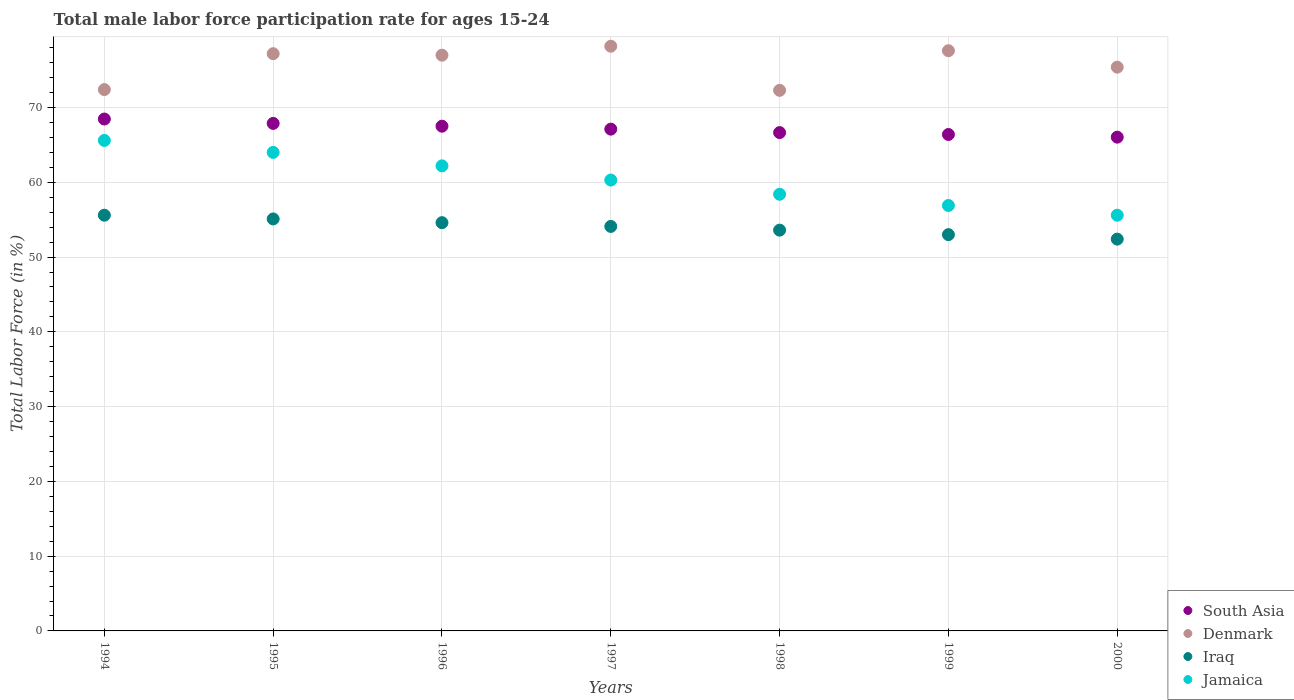How many different coloured dotlines are there?
Your response must be concise. 4. Is the number of dotlines equal to the number of legend labels?
Your answer should be very brief. Yes. What is the male labor force participation rate in Denmark in 1996?
Provide a succinct answer. 77. Across all years, what is the maximum male labor force participation rate in Iraq?
Ensure brevity in your answer.  55.6. Across all years, what is the minimum male labor force participation rate in Jamaica?
Give a very brief answer. 55.6. In which year was the male labor force participation rate in South Asia minimum?
Ensure brevity in your answer.  2000. What is the total male labor force participation rate in Iraq in the graph?
Make the answer very short. 378.4. What is the difference between the male labor force participation rate in Iraq in 1996 and that in 1999?
Give a very brief answer. 1.6. What is the difference between the male labor force participation rate in South Asia in 1998 and the male labor force participation rate in Jamaica in 1999?
Your answer should be very brief. 9.75. What is the average male labor force participation rate in Denmark per year?
Make the answer very short. 75.73. In the year 2000, what is the difference between the male labor force participation rate in Jamaica and male labor force participation rate in South Asia?
Your answer should be compact. -10.44. What is the ratio of the male labor force participation rate in Denmark in 1996 to that in 1999?
Offer a terse response. 0.99. Is the difference between the male labor force participation rate in Jamaica in 1996 and 1997 greater than the difference between the male labor force participation rate in South Asia in 1996 and 1997?
Your answer should be compact. Yes. What is the difference between the highest and the second highest male labor force participation rate in South Asia?
Provide a short and direct response. 0.58. What is the difference between the highest and the lowest male labor force participation rate in South Asia?
Your response must be concise. 2.42. In how many years, is the male labor force participation rate in Denmark greater than the average male labor force participation rate in Denmark taken over all years?
Make the answer very short. 4. Is the male labor force participation rate in Jamaica strictly greater than the male labor force participation rate in Iraq over the years?
Your response must be concise. Yes. Is the male labor force participation rate in Jamaica strictly less than the male labor force participation rate in Iraq over the years?
Your answer should be compact. No. Are the values on the major ticks of Y-axis written in scientific E-notation?
Your answer should be very brief. No. Where does the legend appear in the graph?
Keep it short and to the point. Bottom right. What is the title of the graph?
Keep it short and to the point. Total male labor force participation rate for ages 15-24. What is the label or title of the Y-axis?
Provide a short and direct response. Total Labor Force (in %). What is the Total Labor Force (in %) in South Asia in 1994?
Your answer should be very brief. 68.46. What is the Total Labor Force (in %) of Denmark in 1994?
Your response must be concise. 72.4. What is the Total Labor Force (in %) in Iraq in 1994?
Make the answer very short. 55.6. What is the Total Labor Force (in %) of Jamaica in 1994?
Your response must be concise. 65.6. What is the Total Labor Force (in %) of South Asia in 1995?
Keep it short and to the point. 67.88. What is the Total Labor Force (in %) in Denmark in 1995?
Ensure brevity in your answer.  77.2. What is the Total Labor Force (in %) in Iraq in 1995?
Make the answer very short. 55.1. What is the Total Labor Force (in %) of South Asia in 1996?
Offer a very short reply. 67.5. What is the Total Labor Force (in %) in Iraq in 1996?
Give a very brief answer. 54.6. What is the Total Labor Force (in %) of Jamaica in 1996?
Provide a succinct answer. 62.2. What is the Total Labor Force (in %) of South Asia in 1997?
Your answer should be compact. 67.11. What is the Total Labor Force (in %) of Denmark in 1997?
Ensure brevity in your answer.  78.2. What is the Total Labor Force (in %) in Iraq in 1997?
Your answer should be very brief. 54.1. What is the Total Labor Force (in %) in Jamaica in 1997?
Offer a terse response. 60.3. What is the Total Labor Force (in %) in South Asia in 1998?
Keep it short and to the point. 66.65. What is the Total Labor Force (in %) in Denmark in 1998?
Your response must be concise. 72.3. What is the Total Labor Force (in %) in Iraq in 1998?
Your response must be concise. 53.6. What is the Total Labor Force (in %) in Jamaica in 1998?
Ensure brevity in your answer.  58.4. What is the Total Labor Force (in %) in South Asia in 1999?
Provide a short and direct response. 66.4. What is the Total Labor Force (in %) of Denmark in 1999?
Provide a succinct answer. 77.6. What is the Total Labor Force (in %) in Iraq in 1999?
Give a very brief answer. 53. What is the Total Labor Force (in %) of Jamaica in 1999?
Offer a very short reply. 56.9. What is the Total Labor Force (in %) in South Asia in 2000?
Provide a succinct answer. 66.04. What is the Total Labor Force (in %) of Denmark in 2000?
Offer a very short reply. 75.4. What is the Total Labor Force (in %) in Iraq in 2000?
Provide a succinct answer. 52.4. What is the Total Labor Force (in %) in Jamaica in 2000?
Provide a succinct answer. 55.6. Across all years, what is the maximum Total Labor Force (in %) of South Asia?
Provide a succinct answer. 68.46. Across all years, what is the maximum Total Labor Force (in %) of Denmark?
Offer a terse response. 78.2. Across all years, what is the maximum Total Labor Force (in %) of Iraq?
Your answer should be compact. 55.6. Across all years, what is the maximum Total Labor Force (in %) in Jamaica?
Ensure brevity in your answer.  65.6. Across all years, what is the minimum Total Labor Force (in %) of South Asia?
Provide a succinct answer. 66.04. Across all years, what is the minimum Total Labor Force (in %) of Denmark?
Offer a terse response. 72.3. Across all years, what is the minimum Total Labor Force (in %) in Iraq?
Your response must be concise. 52.4. Across all years, what is the minimum Total Labor Force (in %) in Jamaica?
Your answer should be compact. 55.6. What is the total Total Labor Force (in %) in South Asia in the graph?
Your answer should be compact. 470.04. What is the total Total Labor Force (in %) in Denmark in the graph?
Keep it short and to the point. 530.1. What is the total Total Labor Force (in %) of Iraq in the graph?
Offer a very short reply. 378.4. What is the total Total Labor Force (in %) of Jamaica in the graph?
Your answer should be compact. 423. What is the difference between the Total Labor Force (in %) of South Asia in 1994 and that in 1995?
Your answer should be very brief. 0.58. What is the difference between the Total Labor Force (in %) of Denmark in 1994 and that in 1995?
Make the answer very short. -4.8. What is the difference between the Total Labor Force (in %) of Iraq in 1994 and that in 1995?
Make the answer very short. 0.5. What is the difference between the Total Labor Force (in %) of Jamaica in 1994 and that in 1995?
Your response must be concise. 1.6. What is the difference between the Total Labor Force (in %) of South Asia in 1994 and that in 1996?
Give a very brief answer. 0.96. What is the difference between the Total Labor Force (in %) of Denmark in 1994 and that in 1996?
Your answer should be very brief. -4.6. What is the difference between the Total Labor Force (in %) in Jamaica in 1994 and that in 1996?
Provide a succinct answer. 3.4. What is the difference between the Total Labor Force (in %) of South Asia in 1994 and that in 1997?
Keep it short and to the point. 1.35. What is the difference between the Total Labor Force (in %) of Iraq in 1994 and that in 1997?
Keep it short and to the point. 1.5. What is the difference between the Total Labor Force (in %) of South Asia in 1994 and that in 1998?
Your answer should be compact. 1.81. What is the difference between the Total Labor Force (in %) in South Asia in 1994 and that in 1999?
Provide a succinct answer. 2.07. What is the difference between the Total Labor Force (in %) in Denmark in 1994 and that in 1999?
Your answer should be very brief. -5.2. What is the difference between the Total Labor Force (in %) in Jamaica in 1994 and that in 1999?
Give a very brief answer. 8.7. What is the difference between the Total Labor Force (in %) in South Asia in 1994 and that in 2000?
Offer a terse response. 2.42. What is the difference between the Total Labor Force (in %) of Denmark in 1994 and that in 2000?
Make the answer very short. -3. What is the difference between the Total Labor Force (in %) of Jamaica in 1994 and that in 2000?
Offer a terse response. 10. What is the difference between the Total Labor Force (in %) in South Asia in 1995 and that in 1996?
Ensure brevity in your answer.  0.37. What is the difference between the Total Labor Force (in %) in Jamaica in 1995 and that in 1996?
Your answer should be very brief. 1.8. What is the difference between the Total Labor Force (in %) of South Asia in 1995 and that in 1997?
Your answer should be compact. 0.77. What is the difference between the Total Labor Force (in %) of Denmark in 1995 and that in 1997?
Ensure brevity in your answer.  -1. What is the difference between the Total Labor Force (in %) of Iraq in 1995 and that in 1997?
Keep it short and to the point. 1. What is the difference between the Total Labor Force (in %) of South Asia in 1995 and that in 1998?
Your answer should be compact. 1.23. What is the difference between the Total Labor Force (in %) in Denmark in 1995 and that in 1998?
Keep it short and to the point. 4.9. What is the difference between the Total Labor Force (in %) in South Asia in 1995 and that in 1999?
Provide a succinct answer. 1.48. What is the difference between the Total Labor Force (in %) of Iraq in 1995 and that in 1999?
Offer a terse response. 2.1. What is the difference between the Total Labor Force (in %) of Jamaica in 1995 and that in 1999?
Make the answer very short. 7.1. What is the difference between the Total Labor Force (in %) of South Asia in 1995 and that in 2000?
Your answer should be compact. 1.84. What is the difference between the Total Labor Force (in %) of Denmark in 1995 and that in 2000?
Your answer should be compact. 1.8. What is the difference between the Total Labor Force (in %) in Jamaica in 1995 and that in 2000?
Your response must be concise. 8.4. What is the difference between the Total Labor Force (in %) of South Asia in 1996 and that in 1997?
Make the answer very short. 0.39. What is the difference between the Total Labor Force (in %) of Iraq in 1996 and that in 1997?
Ensure brevity in your answer.  0.5. What is the difference between the Total Labor Force (in %) in Jamaica in 1996 and that in 1997?
Your answer should be compact. 1.9. What is the difference between the Total Labor Force (in %) of South Asia in 1996 and that in 1998?
Offer a terse response. 0.86. What is the difference between the Total Labor Force (in %) in Denmark in 1996 and that in 1998?
Provide a succinct answer. 4.7. What is the difference between the Total Labor Force (in %) in Iraq in 1996 and that in 1998?
Your response must be concise. 1. What is the difference between the Total Labor Force (in %) in South Asia in 1996 and that in 1999?
Provide a short and direct response. 1.11. What is the difference between the Total Labor Force (in %) of Denmark in 1996 and that in 1999?
Provide a succinct answer. -0.6. What is the difference between the Total Labor Force (in %) in Iraq in 1996 and that in 1999?
Offer a terse response. 1.6. What is the difference between the Total Labor Force (in %) in South Asia in 1996 and that in 2000?
Provide a short and direct response. 1.47. What is the difference between the Total Labor Force (in %) of Denmark in 1996 and that in 2000?
Offer a very short reply. 1.6. What is the difference between the Total Labor Force (in %) of Iraq in 1996 and that in 2000?
Provide a succinct answer. 2.2. What is the difference between the Total Labor Force (in %) in South Asia in 1997 and that in 1998?
Ensure brevity in your answer.  0.46. What is the difference between the Total Labor Force (in %) in South Asia in 1997 and that in 1999?
Your response must be concise. 0.72. What is the difference between the Total Labor Force (in %) in Iraq in 1997 and that in 1999?
Offer a terse response. 1.1. What is the difference between the Total Labor Force (in %) of Jamaica in 1997 and that in 1999?
Keep it short and to the point. 3.4. What is the difference between the Total Labor Force (in %) of South Asia in 1997 and that in 2000?
Your answer should be very brief. 1.07. What is the difference between the Total Labor Force (in %) of Iraq in 1997 and that in 2000?
Your answer should be compact. 1.7. What is the difference between the Total Labor Force (in %) in South Asia in 1998 and that in 1999?
Give a very brief answer. 0.25. What is the difference between the Total Labor Force (in %) of Denmark in 1998 and that in 1999?
Ensure brevity in your answer.  -5.3. What is the difference between the Total Labor Force (in %) in Iraq in 1998 and that in 1999?
Offer a very short reply. 0.6. What is the difference between the Total Labor Force (in %) of Jamaica in 1998 and that in 1999?
Your answer should be compact. 1.5. What is the difference between the Total Labor Force (in %) of South Asia in 1998 and that in 2000?
Make the answer very short. 0.61. What is the difference between the Total Labor Force (in %) in Denmark in 1998 and that in 2000?
Provide a short and direct response. -3.1. What is the difference between the Total Labor Force (in %) of South Asia in 1999 and that in 2000?
Your answer should be compact. 0.36. What is the difference between the Total Labor Force (in %) in Iraq in 1999 and that in 2000?
Offer a very short reply. 0.6. What is the difference between the Total Labor Force (in %) in Jamaica in 1999 and that in 2000?
Your answer should be very brief. 1.3. What is the difference between the Total Labor Force (in %) of South Asia in 1994 and the Total Labor Force (in %) of Denmark in 1995?
Your answer should be compact. -8.74. What is the difference between the Total Labor Force (in %) in South Asia in 1994 and the Total Labor Force (in %) in Iraq in 1995?
Provide a short and direct response. 13.36. What is the difference between the Total Labor Force (in %) in South Asia in 1994 and the Total Labor Force (in %) in Jamaica in 1995?
Offer a very short reply. 4.46. What is the difference between the Total Labor Force (in %) of Denmark in 1994 and the Total Labor Force (in %) of Jamaica in 1995?
Ensure brevity in your answer.  8.4. What is the difference between the Total Labor Force (in %) of Iraq in 1994 and the Total Labor Force (in %) of Jamaica in 1995?
Your answer should be very brief. -8.4. What is the difference between the Total Labor Force (in %) of South Asia in 1994 and the Total Labor Force (in %) of Denmark in 1996?
Offer a terse response. -8.54. What is the difference between the Total Labor Force (in %) of South Asia in 1994 and the Total Labor Force (in %) of Iraq in 1996?
Keep it short and to the point. 13.86. What is the difference between the Total Labor Force (in %) in South Asia in 1994 and the Total Labor Force (in %) in Jamaica in 1996?
Provide a short and direct response. 6.26. What is the difference between the Total Labor Force (in %) in Iraq in 1994 and the Total Labor Force (in %) in Jamaica in 1996?
Your answer should be very brief. -6.6. What is the difference between the Total Labor Force (in %) in South Asia in 1994 and the Total Labor Force (in %) in Denmark in 1997?
Your answer should be very brief. -9.74. What is the difference between the Total Labor Force (in %) of South Asia in 1994 and the Total Labor Force (in %) of Iraq in 1997?
Your answer should be very brief. 14.36. What is the difference between the Total Labor Force (in %) of South Asia in 1994 and the Total Labor Force (in %) of Jamaica in 1997?
Provide a succinct answer. 8.16. What is the difference between the Total Labor Force (in %) in South Asia in 1994 and the Total Labor Force (in %) in Denmark in 1998?
Keep it short and to the point. -3.84. What is the difference between the Total Labor Force (in %) in South Asia in 1994 and the Total Labor Force (in %) in Iraq in 1998?
Your response must be concise. 14.86. What is the difference between the Total Labor Force (in %) of South Asia in 1994 and the Total Labor Force (in %) of Jamaica in 1998?
Give a very brief answer. 10.06. What is the difference between the Total Labor Force (in %) in South Asia in 1994 and the Total Labor Force (in %) in Denmark in 1999?
Provide a succinct answer. -9.14. What is the difference between the Total Labor Force (in %) of South Asia in 1994 and the Total Labor Force (in %) of Iraq in 1999?
Offer a very short reply. 15.46. What is the difference between the Total Labor Force (in %) of South Asia in 1994 and the Total Labor Force (in %) of Jamaica in 1999?
Your answer should be very brief. 11.56. What is the difference between the Total Labor Force (in %) in Denmark in 1994 and the Total Labor Force (in %) in Iraq in 1999?
Ensure brevity in your answer.  19.4. What is the difference between the Total Labor Force (in %) in Iraq in 1994 and the Total Labor Force (in %) in Jamaica in 1999?
Give a very brief answer. -1.3. What is the difference between the Total Labor Force (in %) of South Asia in 1994 and the Total Labor Force (in %) of Denmark in 2000?
Your response must be concise. -6.94. What is the difference between the Total Labor Force (in %) in South Asia in 1994 and the Total Labor Force (in %) in Iraq in 2000?
Your answer should be very brief. 16.06. What is the difference between the Total Labor Force (in %) in South Asia in 1994 and the Total Labor Force (in %) in Jamaica in 2000?
Provide a short and direct response. 12.86. What is the difference between the Total Labor Force (in %) of Denmark in 1994 and the Total Labor Force (in %) of Iraq in 2000?
Provide a succinct answer. 20. What is the difference between the Total Labor Force (in %) of Iraq in 1994 and the Total Labor Force (in %) of Jamaica in 2000?
Keep it short and to the point. 0. What is the difference between the Total Labor Force (in %) of South Asia in 1995 and the Total Labor Force (in %) of Denmark in 1996?
Make the answer very short. -9.12. What is the difference between the Total Labor Force (in %) in South Asia in 1995 and the Total Labor Force (in %) in Iraq in 1996?
Make the answer very short. 13.28. What is the difference between the Total Labor Force (in %) of South Asia in 1995 and the Total Labor Force (in %) of Jamaica in 1996?
Offer a very short reply. 5.68. What is the difference between the Total Labor Force (in %) in Denmark in 1995 and the Total Labor Force (in %) in Iraq in 1996?
Your answer should be compact. 22.6. What is the difference between the Total Labor Force (in %) in Iraq in 1995 and the Total Labor Force (in %) in Jamaica in 1996?
Offer a terse response. -7.1. What is the difference between the Total Labor Force (in %) of South Asia in 1995 and the Total Labor Force (in %) of Denmark in 1997?
Make the answer very short. -10.32. What is the difference between the Total Labor Force (in %) of South Asia in 1995 and the Total Labor Force (in %) of Iraq in 1997?
Provide a short and direct response. 13.78. What is the difference between the Total Labor Force (in %) in South Asia in 1995 and the Total Labor Force (in %) in Jamaica in 1997?
Provide a succinct answer. 7.58. What is the difference between the Total Labor Force (in %) in Denmark in 1995 and the Total Labor Force (in %) in Iraq in 1997?
Offer a terse response. 23.1. What is the difference between the Total Labor Force (in %) in Denmark in 1995 and the Total Labor Force (in %) in Jamaica in 1997?
Offer a very short reply. 16.9. What is the difference between the Total Labor Force (in %) in Iraq in 1995 and the Total Labor Force (in %) in Jamaica in 1997?
Offer a terse response. -5.2. What is the difference between the Total Labor Force (in %) in South Asia in 1995 and the Total Labor Force (in %) in Denmark in 1998?
Your answer should be very brief. -4.42. What is the difference between the Total Labor Force (in %) of South Asia in 1995 and the Total Labor Force (in %) of Iraq in 1998?
Provide a succinct answer. 14.28. What is the difference between the Total Labor Force (in %) of South Asia in 1995 and the Total Labor Force (in %) of Jamaica in 1998?
Give a very brief answer. 9.48. What is the difference between the Total Labor Force (in %) of Denmark in 1995 and the Total Labor Force (in %) of Iraq in 1998?
Your answer should be very brief. 23.6. What is the difference between the Total Labor Force (in %) in Denmark in 1995 and the Total Labor Force (in %) in Jamaica in 1998?
Offer a very short reply. 18.8. What is the difference between the Total Labor Force (in %) of Iraq in 1995 and the Total Labor Force (in %) of Jamaica in 1998?
Ensure brevity in your answer.  -3.3. What is the difference between the Total Labor Force (in %) of South Asia in 1995 and the Total Labor Force (in %) of Denmark in 1999?
Provide a short and direct response. -9.72. What is the difference between the Total Labor Force (in %) in South Asia in 1995 and the Total Labor Force (in %) in Iraq in 1999?
Your answer should be very brief. 14.88. What is the difference between the Total Labor Force (in %) in South Asia in 1995 and the Total Labor Force (in %) in Jamaica in 1999?
Make the answer very short. 10.98. What is the difference between the Total Labor Force (in %) in Denmark in 1995 and the Total Labor Force (in %) in Iraq in 1999?
Provide a succinct answer. 24.2. What is the difference between the Total Labor Force (in %) of Denmark in 1995 and the Total Labor Force (in %) of Jamaica in 1999?
Provide a succinct answer. 20.3. What is the difference between the Total Labor Force (in %) in Iraq in 1995 and the Total Labor Force (in %) in Jamaica in 1999?
Ensure brevity in your answer.  -1.8. What is the difference between the Total Labor Force (in %) of South Asia in 1995 and the Total Labor Force (in %) of Denmark in 2000?
Offer a terse response. -7.52. What is the difference between the Total Labor Force (in %) of South Asia in 1995 and the Total Labor Force (in %) of Iraq in 2000?
Your answer should be compact. 15.48. What is the difference between the Total Labor Force (in %) in South Asia in 1995 and the Total Labor Force (in %) in Jamaica in 2000?
Your answer should be compact. 12.28. What is the difference between the Total Labor Force (in %) of Denmark in 1995 and the Total Labor Force (in %) of Iraq in 2000?
Your answer should be very brief. 24.8. What is the difference between the Total Labor Force (in %) of Denmark in 1995 and the Total Labor Force (in %) of Jamaica in 2000?
Ensure brevity in your answer.  21.6. What is the difference between the Total Labor Force (in %) in South Asia in 1996 and the Total Labor Force (in %) in Denmark in 1997?
Provide a short and direct response. -10.7. What is the difference between the Total Labor Force (in %) of South Asia in 1996 and the Total Labor Force (in %) of Iraq in 1997?
Your response must be concise. 13.4. What is the difference between the Total Labor Force (in %) of South Asia in 1996 and the Total Labor Force (in %) of Jamaica in 1997?
Provide a short and direct response. 7.2. What is the difference between the Total Labor Force (in %) of Denmark in 1996 and the Total Labor Force (in %) of Iraq in 1997?
Keep it short and to the point. 22.9. What is the difference between the Total Labor Force (in %) of Iraq in 1996 and the Total Labor Force (in %) of Jamaica in 1997?
Give a very brief answer. -5.7. What is the difference between the Total Labor Force (in %) in South Asia in 1996 and the Total Labor Force (in %) in Denmark in 1998?
Offer a terse response. -4.8. What is the difference between the Total Labor Force (in %) of South Asia in 1996 and the Total Labor Force (in %) of Iraq in 1998?
Make the answer very short. 13.9. What is the difference between the Total Labor Force (in %) of South Asia in 1996 and the Total Labor Force (in %) of Jamaica in 1998?
Ensure brevity in your answer.  9.1. What is the difference between the Total Labor Force (in %) of Denmark in 1996 and the Total Labor Force (in %) of Iraq in 1998?
Offer a very short reply. 23.4. What is the difference between the Total Labor Force (in %) in Denmark in 1996 and the Total Labor Force (in %) in Jamaica in 1998?
Ensure brevity in your answer.  18.6. What is the difference between the Total Labor Force (in %) of South Asia in 1996 and the Total Labor Force (in %) of Denmark in 1999?
Keep it short and to the point. -10.1. What is the difference between the Total Labor Force (in %) of South Asia in 1996 and the Total Labor Force (in %) of Iraq in 1999?
Ensure brevity in your answer.  14.5. What is the difference between the Total Labor Force (in %) of South Asia in 1996 and the Total Labor Force (in %) of Jamaica in 1999?
Offer a very short reply. 10.6. What is the difference between the Total Labor Force (in %) of Denmark in 1996 and the Total Labor Force (in %) of Jamaica in 1999?
Your response must be concise. 20.1. What is the difference between the Total Labor Force (in %) of South Asia in 1996 and the Total Labor Force (in %) of Denmark in 2000?
Keep it short and to the point. -7.9. What is the difference between the Total Labor Force (in %) of South Asia in 1996 and the Total Labor Force (in %) of Iraq in 2000?
Make the answer very short. 15.1. What is the difference between the Total Labor Force (in %) of South Asia in 1996 and the Total Labor Force (in %) of Jamaica in 2000?
Offer a very short reply. 11.9. What is the difference between the Total Labor Force (in %) of Denmark in 1996 and the Total Labor Force (in %) of Iraq in 2000?
Make the answer very short. 24.6. What is the difference between the Total Labor Force (in %) in Denmark in 1996 and the Total Labor Force (in %) in Jamaica in 2000?
Your response must be concise. 21.4. What is the difference between the Total Labor Force (in %) in South Asia in 1997 and the Total Labor Force (in %) in Denmark in 1998?
Offer a terse response. -5.19. What is the difference between the Total Labor Force (in %) in South Asia in 1997 and the Total Labor Force (in %) in Iraq in 1998?
Offer a terse response. 13.51. What is the difference between the Total Labor Force (in %) of South Asia in 1997 and the Total Labor Force (in %) of Jamaica in 1998?
Ensure brevity in your answer.  8.71. What is the difference between the Total Labor Force (in %) of Denmark in 1997 and the Total Labor Force (in %) of Iraq in 1998?
Make the answer very short. 24.6. What is the difference between the Total Labor Force (in %) of Denmark in 1997 and the Total Labor Force (in %) of Jamaica in 1998?
Give a very brief answer. 19.8. What is the difference between the Total Labor Force (in %) of South Asia in 1997 and the Total Labor Force (in %) of Denmark in 1999?
Your response must be concise. -10.49. What is the difference between the Total Labor Force (in %) of South Asia in 1997 and the Total Labor Force (in %) of Iraq in 1999?
Make the answer very short. 14.11. What is the difference between the Total Labor Force (in %) of South Asia in 1997 and the Total Labor Force (in %) of Jamaica in 1999?
Offer a very short reply. 10.21. What is the difference between the Total Labor Force (in %) of Denmark in 1997 and the Total Labor Force (in %) of Iraq in 1999?
Keep it short and to the point. 25.2. What is the difference between the Total Labor Force (in %) of Denmark in 1997 and the Total Labor Force (in %) of Jamaica in 1999?
Ensure brevity in your answer.  21.3. What is the difference between the Total Labor Force (in %) of South Asia in 1997 and the Total Labor Force (in %) of Denmark in 2000?
Keep it short and to the point. -8.29. What is the difference between the Total Labor Force (in %) in South Asia in 1997 and the Total Labor Force (in %) in Iraq in 2000?
Give a very brief answer. 14.71. What is the difference between the Total Labor Force (in %) of South Asia in 1997 and the Total Labor Force (in %) of Jamaica in 2000?
Offer a terse response. 11.51. What is the difference between the Total Labor Force (in %) in Denmark in 1997 and the Total Labor Force (in %) in Iraq in 2000?
Provide a succinct answer. 25.8. What is the difference between the Total Labor Force (in %) of Denmark in 1997 and the Total Labor Force (in %) of Jamaica in 2000?
Ensure brevity in your answer.  22.6. What is the difference between the Total Labor Force (in %) of Iraq in 1997 and the Total Labor Force (in %) of Jamaica in 2000?
Give a very brief answer. -1.5. What is the difference between the Total Labor Force (in %) in South Asia in 1998 and the Total Labor Force (in %) in Denmark in 1999?
Keep it short and to the point. -10.95. What is the difference between the Total Labor Force (in %) in South Asia in 1998 and the Total Labor Force (in %) in Iraq in 1999?
Offer a terse response. 13.65. What is the difference between the Total Labor Force (in %) of South Asia in 1998 and the Total Labor Force (in %) of Jamaica in 1999?
Provide a short and direct response. 9.75. What is the difference between the Total Labor Force (in %) of Denmark in 1998 and the Total Labor Force (in %) of Iraq in 1999?
Your answer should be compact. 19.3. What is the difference between the Total Labor Force (in %) in Iraq in 1998 and the Total Labor Force (in %) in Jamaica in 1999?
Give a very brief answer. -3.3. What is the difference between the Total Labor Force (in %) of South Asia in 1998 and the Total Labor Force (in %) of Denmark in 2000?
Your response must be concise. -8.75. What is the difference between the Total Labor Force (in %) in South Asia in 1998 and the Total Labor Force (in %) in Iraq in 2000?
Provide a short and direct response. 14.25. What is the difference between the Total Labor Force (in %) of South Asia in 1998 and the Total Labor Force (in %) of Jamaica in 2000?
Offer a very short reply. 11.05. What is the difference between the Total Labor Force (in %) of Iraq in 1998 and the Total Labor Force (in %) of Jamaica in 2000?
Your response must be concise. -2. What is the difference between the Total Labor Force (in %) in South Asia in 1999 and the Total Labor Force (in %) in Denmark in 2000?
Provide a short and direct response. -9. What is the difference between the Total Labor Force (in %) in South Asia in 1999 and the Total Labor Force (in %) in Iraq in 2000?
Ensure brevity in your answer.  14. What is the difference between the Total Labor Force (in %) in South Asia in 1999 and the Total Labor Force (in %) in Jamaica in 2000?
Give a very brief answer. 10.8. What is the difference between the Total Labor Force (in %) of Denmark in 1999 and the Total Labor Force (in %) of Iraq in 2000?
Make the answer very short. 25.2. What is the difference between the Total Labor Force (in %) in Iraq in 1999 and the Total Labor Force (in %) in Jamaica in 2000?
Your response must be concise. -2.6. What is the average Total Labor Force (in %) of South Asia per year?
Keep it short and to the point. 67.15. What is the average Total Labor Force (in %) of Denmark per year?
Give a very brief answer. 75.73. What is the average Total Labor Force (in %) of Iraq per year?
Ensure brevity in your answer.  54.06. What is the average Total Labor Force (in %) in Jamaica per year?
Offer a terse response. 60.43. In the year 1994, what is the difference between the Total Labor Force (in %) of South Asia and Total Labor Force (in %) of Denmark?
Provide a succinct answer. -3.94. In the year 1994, what is the difference between the Total Labor Force (in %) in South Asia and Total Labor Force (in %) in Iraq?
Make the answer very short. 12.86. In the year 1994, what is the difference between the Total Labor Force (in %) in South Asia and Total Labor Force (in %) in Jamaica?
Your answer should be compact. 2.86. In the year 1994, what is the difference between the Total Labor Force (in %) of Denmark and Total Labor Force (in %) of Jamaica?
Keep it short and to the point. 6.8. In the year 1994, what is the difference between the Total Labor Force (in %) in Iraq and Total Labor Force (in %) in Jamaica?
Keep it short and to the point. -10. In the year 1995, what is the difference between the Total Labor Force (in %) in South Asia and Total Labor Force (in %) in Denmark?
Offer a very short reply. -9.32. In the year 1995, what is the difference between the Total Labor Force (in %) in South Asia and Total Labor Force (in %) in Iraq?
Offer a terse response. 12.78. In the year 1995, what is the difference between the Total Labor Force (in %) in South Asia and Total Labor Force (in %) in Jamaica?
Your response must be concise. 3.88. In the year 1995, what is the difference between the Total Labor Force (in %) of Denmark and Total Labor Force (in %) of Iraq?
Provide a short and direct response. 22.1. In the year 1996, what is the difference between the Total Labor Force (in %) of South Asia and Total Labor Force (in %) of Denmark?
Make the answer very short. -9.5. In the year 1996, what is the difference between the Total Labor Force (in %) of South Asia and Total Labor Force (in %) of Iraq?
Ensure brevity in your answer.  12.9. In the year 1996, what is the difference between the Total Labor Force (in %) in South Asia and Total Labor Force (in %) in Jamaica?
Give a very brief answer. 5.3. In the year 1996, what is the difference between the Total Labor Force (in %) of Denmark and Total Labor Force (in %) of Iraq?
Your answer should be compact. 22.4. In the year 1996, what is the difference between the Total Labor Force (in %) of Iraq and Total Labor Force (in %) of Jamaica?
Keep it short and to the point. -7.6. In the year 1997, what is the difference between the Total Labor Force (in %) of South Asia and Total Labor Force (in %) of Denmark?
Offer a terse response. -11.09. In the year 1997, what is the difference between the Total Labor Force (in %) of South Asia and Total Labor Force (in %) of Iraq?
Your response must be concise. 13.01. In the year 1997, what is the difference between the Total Labor Force (in %) in South Asia and Total Labor Force (in %) in Jamaica?
Provide a short and direct response. 6.81. In the year 1997, what is the difference between the Total Labor Force (in %) of Denmark and Total Labor Force (in %) of Iraq?
Keep it short and to the point. 24.1. In the year 1997, what is the difference between the Total Labor Force (in %) in Denmark and Total Labor Force (in %) in Jamaica?
Provide a short and direct response. 17.9. In the year 1998, what is the difference between the Total Labor Force (in %) in South Asia and Total Labor Force (in %) in Denmark?
Your response must be concise. -5.65. In the year 1998, what is the difference between the Total Labor Force (in %) in South Asia and Total Labor Force (in %) in Iraq?
Your answer should be compact. 13.05. In the year 1998, what is the difference between the Total Labor Force (in %) in South Asia and Total Labor Force (in %) in Jamaica?
Your answer should be compact. 8.25. In the year 1998, what is the difference between the Total Labor Force (in %) of Denmark and Total Labor Force (in %) of Jamaica?
Offer a terse response. 13.9. In the year 1999, what is the difference between the Total Labor Force (in %) of South Asia and Total Labor Force (in %) of Denmark?
Your response must be concise. -11.2. In the year 1999, what is the difference between the Total Labor Force (in %) of South Asia and Total Labor Force (in %) of Iraq?
Your answer should be compact. 13.4. In the year 1999, what is the difference between the Total Labor Force (in %) of South Asia and Total Labor Force (in %) of Jamaica?
Your answer should be very brief. 9.5. In the year 1999, what is the difference between the Total Labor Force (in %) of Denmark and Total Labor Force (in %) of Iraq?
Your answer should be very brief. 24.6. In the year 1999, what is the difference between the Total Labor Force (in %) of Denmark and Total Labor Force (in %) of Jamaica?
Your answer should be compact. 20.7. In the year 2000, what is the difference between the Total Labor Force (in %) in South Asia and Total Labor Force (in %) in Denmark?
Your answer should be compact. -9.36. In the year 2000, what is the difference between the Total Labor Force (in %) in South Asia and Total Labor Force (in %) in Iraq?
Your response must be concise. 13.64. In the year 2000, what is the difference between the Total Labor Force (in %) in South Asia and Total Labor Force (in %) in Jamaica?
Offer a very short reply. 10.44. In the year 2000, what is the difference between the Total Labor Force (in %) of Denmark and Total Labor Force (in %) of Iraq?
Give a very brief answer. 23. In the year 2000, what is the difference between the Total Labor Force (in %) of Denmark and Total Labor Force (in %) of Jamaica?
Offer a terse response. 19.8. In the year 2000, what is the difference between the Total Labor Force (in %) of Iraq and Total Labor Force (in %) of Jamaica?
Keep it short and to the point. -3.2. What is the ratio of the Total Labor Force (in %) of South Asia in 1994 to that in 1995?
Provide a succinct answer. 1.01. What is the ratio of the Total Labor Force (in %) in Denmark in 1994 to that in 1995?
Offer a very short reply. 0.94. What is the ratio of the Total Labor Force (in %) in Iraq in 1994 to that in 1995?
Give a very brief answer. 1.01. What is the ratio of the Total Labor Force (in %) in Jamaica in 1994 to that in 1995?
Provide a short and direct response. 1.02. What is the ratio of the Total Labor Force (in %) of South Asia in 1994 to that in 1996?
Offer a very short reply. 1.01. What is the ratio of the Total Labor Force (in %) in Denmark in 1994 to that in 1996?
Provide a short and direct response. 0.94. What is the ratio of the Total Labor Force (in %) in Iraq in 1994 to that in 1996?
Your response must be concise. 1.02. What is the ratio of the Total Labor Force (in %) of Jamaica in 1994 to that in 1996?
Ensure brevity in your answer.  1.05. What is the ratio of the Total Labor Force (in %) in South Asia in 1994 to that in 1997?
Your answer should be compact. 1.02. What is the ratio of the Total Labor Force (in %) in Denmark in 1994 to that in 1997?
Make the answer very short. 0.93. What is the ratio of the Total Labor Force (in %) of Iraq in 1994 to that in 1997?
Ensure brevity in your answer.  1.03. What is the ratio of the Total Labor Force (in %) in Jamaica in 1994 to that in 1997?
Offer a very short reply. 1.09. What is the ratio of the Total Labor Force (in %) in South Asia in 1994 to that in 1998?
Make the answer very short. 1.03. What is the ratio of the Total Labor Force (in %) of Denmark in 1994 to that in 1998?
Offer a very short reply. 1. What is the ratio of the Total Labor Force (in %) in Iraq in 1994 to that in 1998?
Provide a short and direct response. 1.04. What is the ratio of the Total Labor Force (in %) of Jamaica in 1994 to that in 1998?
Provide a short and direct response. 1.12. What is the ratio of the Total Labor Force (in %) of South Asia in 1994 to that in 1999?
Keep it short and to the point. 1.03. What is the ratio of the Total Labor Force (in %) of Denmark in 1994 to that in 1999?
Ensure brevity in your answer.  0.93. What is the ratio of the Total Labor Force (in %) of Iraq in 1994 to that in 1999?
Your response must be concise. 1.05. What is the ratio of the Total Labor Force (in %) of Jamaica in 1994 to that in 1999?
Your answer should be very brief. 1.15. What is the ratio of the Total Labor Force (in %) in South Asia in 1994 to that in 2000?
Your answer should be compact. 1.04. What is the ratio of the Total Labor Force (in %) in Denmark in 1994 to that in 2000?
Give a very brief answer. 0.96. What is the ratio of the Total Labor Force (in %) of Iraq in 1994 to that in 2000?
Offer a very short reply. 1.06. What is the ratio of the Total Labor Force (in %) in Jamaica in 1994 to that in 2000?
Ensure brevity in your answer.  1.18. What is the ratio of the Total Labor Force (in %) of South Asia in 1995 to that in 1996?
Offer a terse response. 1.01. What is the ratio of the Total Labor Force (in %) in Denmark in 1995 to that in 1996?
Your response must be concise. 1. What is the ratio of the Total Labor Force (in %) of Iraq in 1995 to that in 1996?
Make the answer very short. 1.01. What is the ratio of the Total Labor Force (in %) of Jamaica in 1995 to that in 1996?
Provide a short and direct response. 1.03. What is the ratio of the Total Labor Force (in %) in South Asia in 1995 to that in 1997?
Your answer should be compact. 1.01. What is the ratio of the Total Labor Force (in %) in Denmark in 1995 to that in 1997?
Offer a terse response. 0.99. What is the ratio of the Total Labor Force (in %) in Iraq in 1995 to that in 1997?
Make the answer very short. 1.02. What is the ratio of the Total Labor Force (in %) in Jamaica in 1995 to that in 1997?
Your answer should be compact. 1.06. What is the ratio of the Total Labor Force (in %) in South Asia in 1995 to that in 1998?
Provide a short and direct response. 1.02. What is the ratio of the Total Labor Force (in %) of Denmark in 1995 to that in 1998?
Your response must be concise. 1.07. What is the ratio of the Total Labor Force (in %) of Iraq in 1995 to that in 1998?
Your answer should be compact. 1.03. What is the ratio of the Total Labor Force (in %) in Jamaica in 1995 to that in 1998?
Your answer should be very brief. 1.1. What is the ratio of the Total Labor Force (in %) in South Asia in 1995 to that in 1999?
Offer a very short reply. 1.02. What is the ratio of the Total Labor Force (in %) in Iraq in 1995 to that in 1999?
Offer a very short reply. 1.04. What is the ratio of the Total Labor Force (in %) of Jamaica in 1995 to that in 1999?
Provide a succinct answer. 1.12. What is the ratio of the Total Labor Force (in %) of South Asia in 1995 to that in 2000?
Offer a very short reply. 1.03. What is the ratio of the Total Labor Force (in %) in Denmark in 1995 to that in 2000?
Make the answer very short. 1.02. What is the ratio of the Total Labor Force (in %) in Iraq in 1995 to that in 2000?
Make the answer very short. 1.05. What is the ratio of the Total Labor Force (in %) of Jamaica in 1995 to that in 2000?
Ensure brevity in your answer.  1.15. What is the ratio of the Total Labor Force (in %) of South Asia in 1996 to that in 1997?
Your response must be concise. 1.01. What is the ratio of the Total Labor Force (in %) in Denmark in 1996 to that in 1997?
Make the answer very short. 0.98. What is the ratio of the Total Labor Force (in %) in Iraq in 1996 to that in 1997?
Your response must be concise. 1.01. What is the ratio of the Total Labor Force (in %) of Jamaica in 1996 to that in 1997?
Give a very brief answer. 1.03. What is the ratio of the Total Labor Force (in %) of South Asia in 1996 to that in 1998?
Offer a very short reply. 1.01. What is the ratio of the Total Labor Force (in %) in Denmark in 1996 to that in 1998?
Provide a short and direct response. 1.06. What is the ratio of the Total Labor Force (in %) of Iraq in 1996 to that in 1998?
Your answer should be very brief. 1.02. What is the ratio of the Total Labor Force (in %) of Jamaica in 1996 to that in 1998?
Your response must be concise. 1.07. What is the ratio of the Total Labor Force (in %) in South Asia in 1996 to that in 1999?
Your answer should be very brief. 1.02. What is the ratio of the Total Labor Force (in %) of Iraq in 1996 to that in 1999?
Keep it short and to the point. 1.03. What is the ratio of the Total Labor Force (in %) of Jamaica in 1996 to that in 1999?
Your response must be concise. 1.09. What is the ratio of the Total Labor Force (in %) in South Asia in 1996 to that in 2000?
Provide a short and direct response. 1.02. What is the ratio of the Total Labor Force (in %) of Denmark in 1996 to that in 2000?
Make the answer very short. 1.02. What is the ratio of the Total Labor Force (in %) of Iraq in 1996 to that in 2000?
Keep it short and to the point. 1.04. What is the ratio of the Total Labor Force (in %) in Jamaica in 1996 to that in 2000?
Offer a terse response. 1.12. What is the ratio of the Total Labor Force (in %) in Denmark in 1997 to that in 1998?
Ensure brevity in your answer.  1.08. What is the ratio of the Total Labor Force (in %) of Iraq in 1997 to that in 1998?
Make the answer very short. 1.01. What is the ratio of the Total Labor Force (in %) of Jamaica in 1997 to that in 1998?
Your answer should be compact. 1.03. What is the ratio of the Total Labor Force (in %) in South Asia in 1997 to that in 1999?
Ensure brevity in your answer.  1.01. What is the ratio of the Total Labor Force (in %) in Denmark in 1997 to that in 1999?
Give a very brief answer. 1.01. What is the ratio of the Total Labor Force (in %) of Iraq in 1997 to that in 1999?
Give a very brief answer. 1.02. What is the ratio of the Total Labor Force (in %) of Jamaica in 1997 to that in 1999?
Your answer should be compact. 1.06. What is the ratio of the Total Labor Force (in %) in South Asia in 1997 to that in 2000?
Offer a terse response. 1.02. What is the ratio of the Total Labor Force (in %) of Denmark in 1997 to that in 2000?
Make the answer very short. 1.04. What is the ratio of the Total Labor Force (in %) of Iraq in 1997 to that in 2000?
Your response must be concise. 1.03. What is the ratio of the Total Labor Force (in %) of Jamaica in 1997 to that in 2000?
Your answer should be compact. 1.08. What is the ratio of the Total Labor Force (in %) of South Asia in 1998 to that in 1999?
Provide a succinct answer. 1. What is the ratio of the Total Labor Force (in %) of Denmark in 1998 to that in 1999?
Ensure brevity in your answer.  0.93. What is the ratio of the Total Labor Force (in %) in Iraq in 1998 to that in 1999?
Offer a terse response. 1.01. What is the ratio of the Total Labor Force (in %) in Jamaica in 1998 to that in 1999?
Your answer should be compact. 1.03. What is the ratio of the Total Labor Force (in %) of South Asia in 1998 to that in 2000?
Your answer should be very brief. 1.01. What is the ratio of the Total Labor Force (in %) in Denmark in 1998 to that in 2000?
Make the answer very short. 0.96. What is the ratio of the Total Labor Force (in %) of Iraq in 1998 to that in 2000?
Ensure brevity in your answer.  1.02. What is the ratio of the Total Labor Force (in %) of Jamaica in 1998 to that in 2000?
Give a very brief answer. 1.05. What is the ratio of the Total Labor Force (in %) in South Asia in 1999 to that in 2000?
Give a very brief answer. 1.01. What is the ratio of the Total Labor Force (in %) in Denmark in 1999 to that in 2000?
Keep it short and to the point. 1.03. What is the ratio of the Total Labor Force (in %) of Iraq in 1999 to that in 2000?
Your response must be concise. 1.01. What is the ratio of the Total Labor Force (in %) in Jamaica in 1999 to that in 2000?
Give a very brief answer. 1.02. What is the difference between the highest and the second highest Total Labor Force (in %) of South Asia?
Give a very brief answer. 0.58. What is the difference between the highest and the second highest Total Labor Force (in %) in Denmark?
Your answer should be compact. 0.6. What is the difference between the highest and the lowest Total Labor Force (in %) in South Asia?
Give a very brief answer. 2.42. What is the difference between the highest and the lowest Total Labor Force (in %) of Denmark?
Ensure brevity in your answer.  5.9. What is the difference between the highest and the lowest Total Labor Force (in %) of Jamaica?
Your answer should be very brief. 10. 